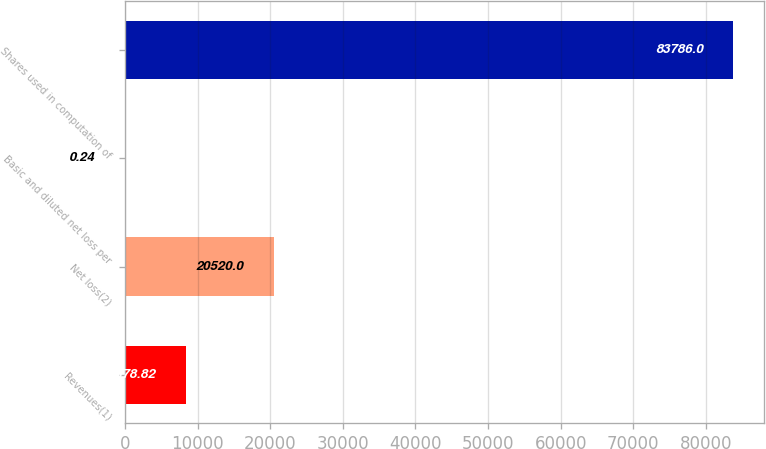Convert chart. <chart><loc_0><loc_0><loc_500><loc_500><bar_chart><fcel>Revenues(1)<fcel>Net loss(2)<fcel>Basic and diluted net loss per<fcel>Shares used in computation of<nl><fcel>8378.82<fcel>20520<fcel>0.24<fcel>83786<nl></chart> 